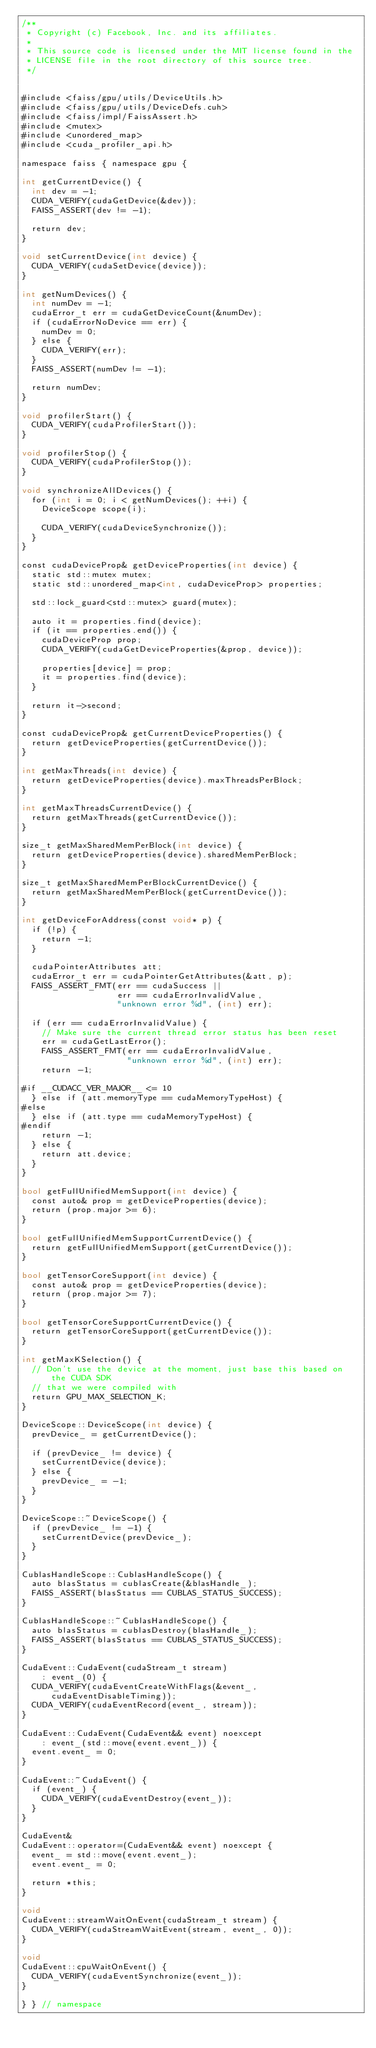<code> <loc_0><loc_0><loc_500><loc_500><_Cuda_>/**
 * Copyright (c) Facebook, Inc. and its affiliates.
 *
 * This source code is licensed under the MIT license found in the
 * LICENSE file in the root directory of this source tree.
 */


#include <faiss/gpu/utils/DeviceUtils.h>
#include <faiss/gpu/utils/DeviceDefs.cuh>
#include <faiss/impl/FaissAssert.h>
#include <mutex>
#include <unordered_map>
#include <cuda_profiler_api.h>

namespace faiss { namespace gpu {

int getCurrentDevice() {
  int dev = -1;
  CUDA_VERIFY(cudaGetDevice(&dev));
  FAISS_ASSERT(dev != -1);

  return dev;
}

void setCurrentDevice(int device) {
  CUDA_VERIFY(cudaSetDevice(device));
}

int getNumDevices() {
  int numDev = -1;
  cudaError_t err = cudaGetDeviceCount(&numDev);
  if (cudaErrorNoDevice == err) {
    numDev = 0;
  } else {
    CUDA_VERIFY(err);
  }
  FAISS_ASSERT(numDev != -1);

  return numDev;
}

void profilerStart() {
  CUDA_VERIFY(cudaProfilerStart());
}

void profilerStop() {
  CUDA_VERIFY(cudaProfilerStop());
}

void synchronizeAllDevices() {
  for (int i = 0; i < getNumDevices(); ++i) {
    DeviceScope scope(i);

    CUDA_VERIFY(cudaDeviceSynchronize());
  }
}

const cudaDeviceProp& getDeviceProperties(int device) {
  static std::mutex mutex;
  static std::unordered_map<int, cudaDeviceProp> properties;

  std::lock_guard<std::mutex> guard(mutex);

  auto it = properties.find(device);
  if (it == properties.end()) {
    cudaDeviceProp prop;
    CUDA_VERIFY(cudaGetDeviceProperties(&prop, device));

    properties[device] = prop;
    it = properties.find(device);
  }

  return it->second;
}

const cudaDeviceProp& getCurrentDeviceProperties() {
  return getDeviceProperties(getCurrentDevice());
}

int getMaxThreads(int device) {
  return getDeviceProperties(device).maxThreadsPerBlock;
}

int getMaxThreadsCurrentDevice() {
  return getMaxThreads(getCurrentDevice());
}

size_t getMaxSharedMemPerBlock(int device) {
  return getDeviceProperties(device).sharedMemPerBlock;
}

size_t getMaxSharedMemPerBlockCurrentDevice() {
  return getMaxSharedMemPerBlock(getCurrentDevice());
}

int getDeviceForAddress(const void* p) {
  if (!p) {
    return -1;
  }

  cudaPointerAttributes att;
  cudaError_t err = cudaPointerGetAttributes(&att, p);
  FAISS_ASSERT_FMT(err == cudaSuccess ||
                   err == cudaErrorInvalidValue,
                   "unknown error %d", (int) err);

  if (err == cudaErrorInvalidValue) {
    // Make sure the current thread error status has been reset
    err = cudaGetLastError();
    FAISS_ASSERT_FMT(err == cudaErrorInvalidValue,
                     "unknown error %d", (int) err);
    return -1;

#if __CUDACC_VER_MAJOR__ <= 10
  } else if (att.memoryType == cudaMemoryTypeHost) {
#else
  } else if (att.type == cudaMemoryTypeHost) {
#endif
    return -1;
  } else {
    return att.device;
  }
}

bool getFullUnifiedMemSupport(int device) {
  const auto& prop = getDeviceProperties(device);
  return (prop.major >= 6);
}

bool getFullUnifiedMemSupportCurrentDevice() {
  return getFullUnifiedMemSupport(getCurrentDevice());
}

bool getTensorCoreSupport(int device) {
  const auto& prop = getDeviceProperties(device);
  return (prop.major >= 7);
}

bool getTensorCoreSupportCurrentDevice() {
  return getTensorCoreSupport(getCurrentDevice());
}

int getMaxKSelection() {
  // Don't use the device at the moment, just base this based on the CUDA SDK
  // that we were compiled with
  return GPU_MAX_SELECTION_K;
}

DeviceScope::DeviceScope(int device) {
  prevDevice_ = getCurrentDevice();

  if (prevDevice_ != device) {
    setCurrentDevice(device);
  } else {
    prevDevice_ = -1;
  }
}

DeviceScope::~DeviceScope() {
  if (prevDevice_ != -1) {
    setCurrentDevice(prevDevice_);
  }
}

CublasHandleScope::CublasHandleScope() {
  auto blasStatus = cublasCreate(&blasHandle_);
  FAISS_ASSERT(blasStatus == CUBLAS_STATUS_SUCCESS);
}

CublasHandleScope::~CublasHandleScope() {
  auto blasStatus = cublasDestroy(blasHandle_);
  FAISS_ASSERT(blasStatus == CUBLAS_STATUS_SUCCESS);
}

CudaEvent::CudaEvent(cudaStream_t stream)
    : event_(0) {
  CUDA_VERIFY(cudaEventCreateWithFlags(&event_, cudaEventDisableTiming));
  CUDA_VERIFY(cudaEventRecord(event_, stream));
}

CudaEvent::CudaEvent(CudaEvent&& event) noexcept
    : event_(std::move(event.event_)) {
  event.event_ = 0;
}

CudaEvent::~CudaEvent() {
  if (event_) {
    CUDA_VERIFY(cudaEventDestroy(event_));
  }
}

CudaEvent&
CudaEvent::operator=(CudaEvent&& event) noexcept {
  event_ = std::move(event.event_);
  event.event_ = 0;

  return *this;
}

void
CudaEvent::streamWaitOnEvent(cudaStream_t stream) {
  CUDA_VERIFY(cudaStreamWaitEvent(stream, event_, 0));
}

void
CudaEvent::cpuWaitOnEvent() {
  CUDA_VERIFY(cudaEventSynchronize(event_));
}

} } // namespace
</code> 